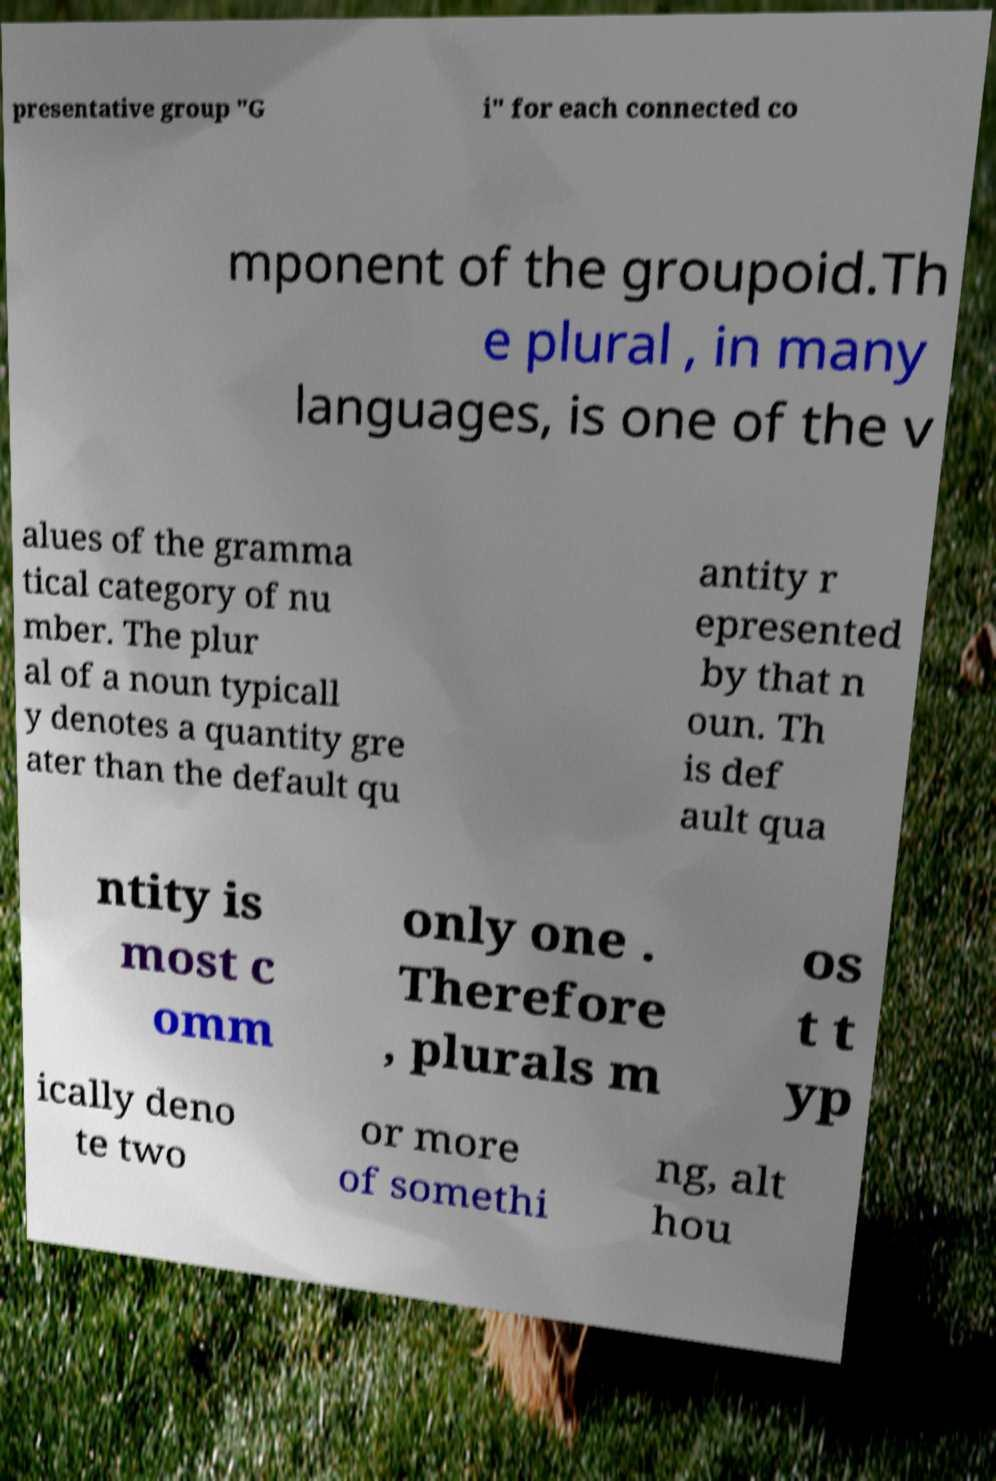What messages or text are displayed in this image? I need them in a readable, typed format. presentative group "G i" for each connected co mponent of the groupoid.Th e plural , in many languages, is one of the v alues of the gramma tical category of nu mber. The plur al of a noun typicall y denotes a quantity gre ater than the default qu antity r epresented by that n oun. Th is def ault qua ntity is most c omm only one . Therefore , plurals m os t t yp ically deno te two or more of somethi ng, alt hou 